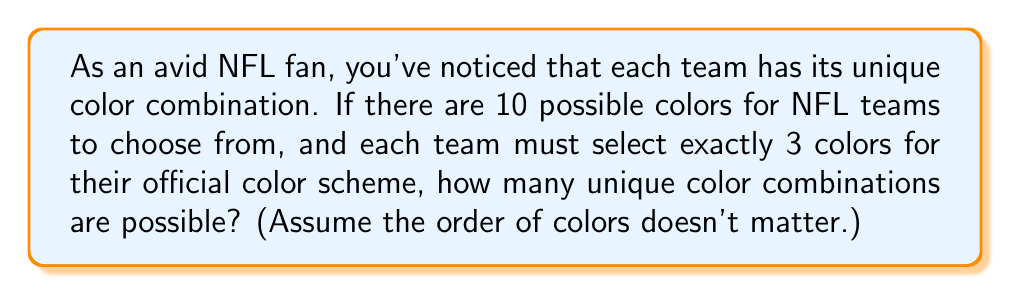Show me your answer to this math problem. Let's approach this problem using set theory and combination principles:

1) We're selecting 3 colors from a set of 10 colors. This is a combination problem because the order doesn't matter (e.g., red-blue-green is considered the same as blue-green-red).

2) In set theory, this is equivalent to finding the number of 3-element subsets of a 10-element set.

3) The formula for this combination is:

   $${n \choose k} = \frac{n!}{k!(n-k)!}$$

   Where $n$ is the total number of elements (colors in this case) and $k$ is the number of elements being chosen.

4) In this problem, $n = 10$ and $k = 3$. Let's substitute these values:

   $${10 \choose 3} = \frac{10!}{3!(10-3)!} = \frac{10!}{3!7!}$$

5) Expand this:
   $$\frac{10 \cdot 9 \cdot 8 \cdot 7!}{(3 \cdot 2 \cdot 1) \cdot 7!}$$

6) The 7! cancels out in the numerator and denominator:
   $$\frac{10 \cdot 9 \cdot 8}{3 \cdot 2 \cdot 1} = \frac{720}{6} = 120$$

Therefore, there are 120 possible unique color combinations for NFL teams under these conditions.
Answer: 120 unique color combinations 